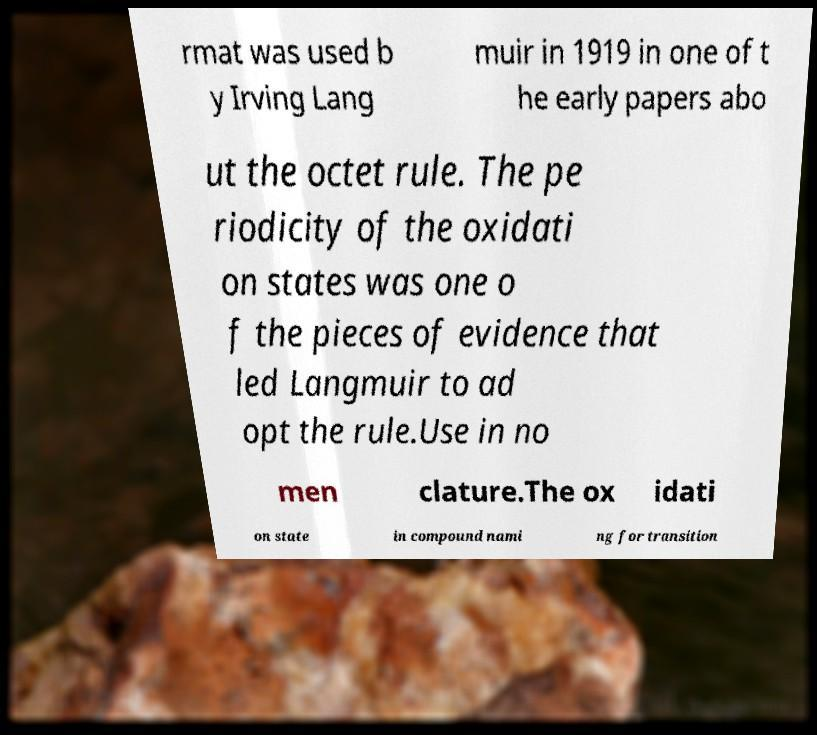Please read and relay the text visible in this image. What does it say? rmat was used b y Irving Lang muir in 1919 in one of t he early papers abo ut the octet rule. The pe riodicity of the oxidati on states was one o f the pieces of evidence that led Langmuir to ad opt the rule.Use in no men clature.The ox idati on state in compound nami ng for transition 